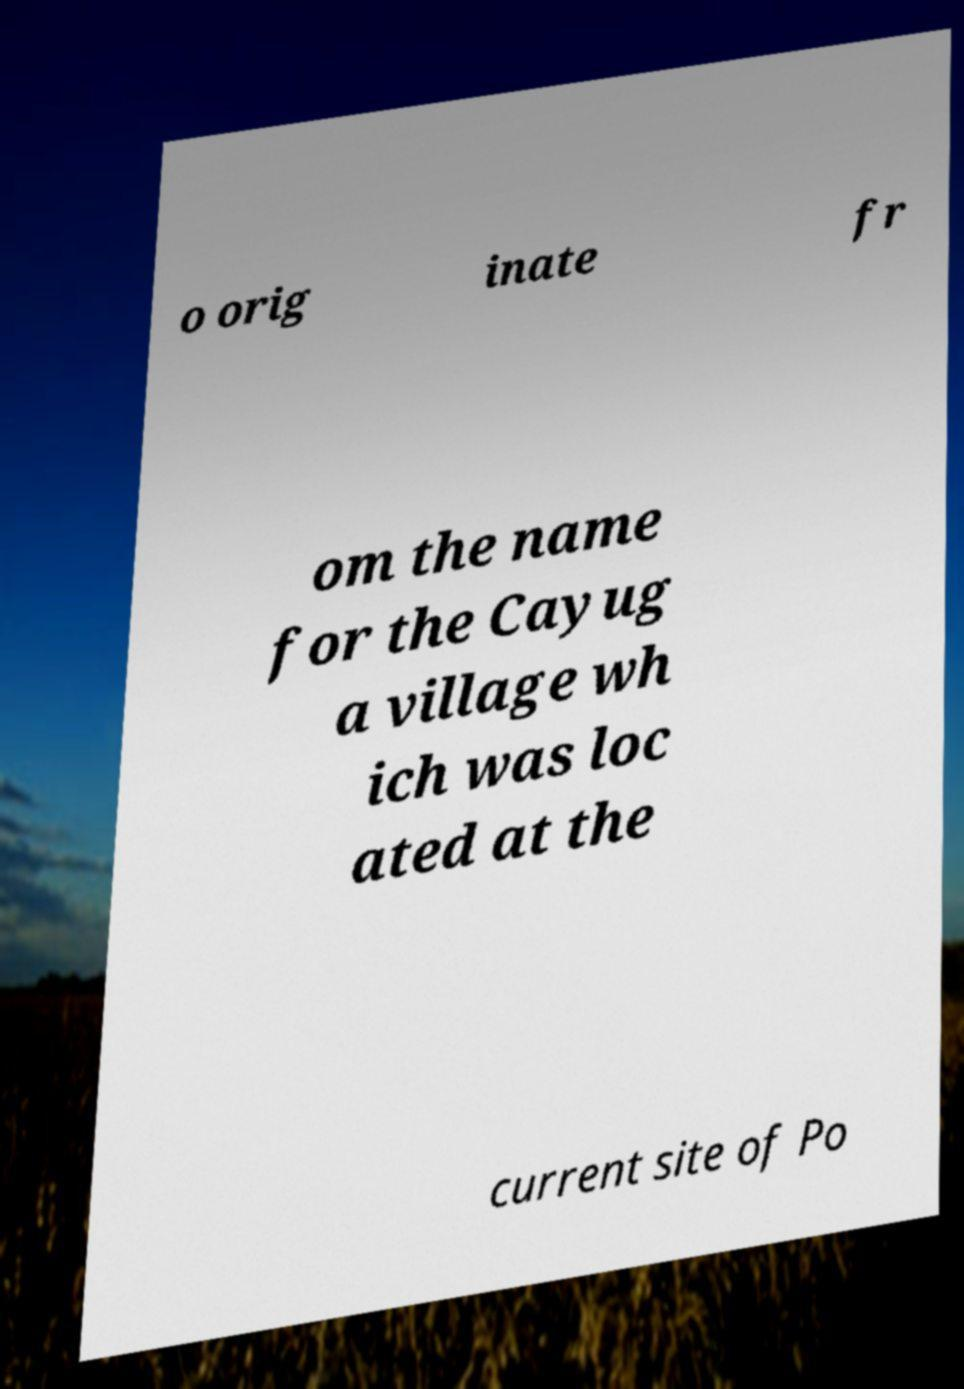Can you accurately transcribe the text from the provided image for me? o orig inate fr om the name for the Cayug a village wh ich was loc ated at the current site of Po 